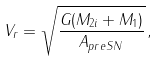<formula> <loc_0><loc_0><loc_500><loc_500>V _ { r } = \sqrt { \frac { G ( M _ { 2 i } + M _ { 1 } ) } { A _ { p r e S N } } } \, ,</formula> 